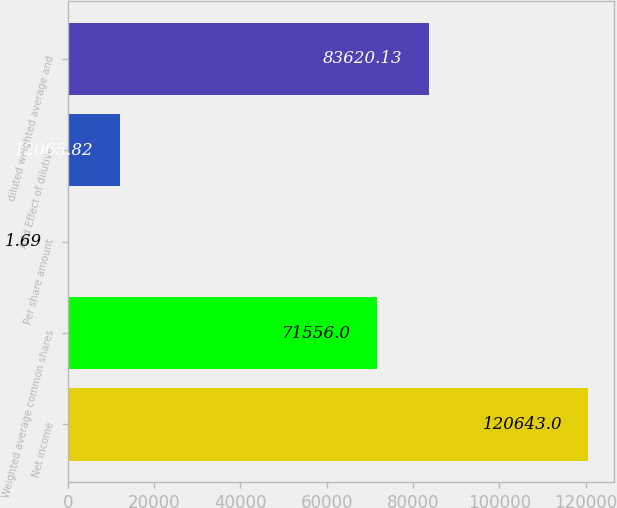<chart> <loc_0><loc_0><loc_500><loc_500><bar_chart><fcel>Net income<fcel>Weighted average common shares<fcel>Per share amount<fcel>Add Effect of dilutive<fcel>diluted weighted average and<nl><fcel>120643<fcel>71556<fcel>1.69<fcel>12065.8<fcel>83620.1<nl></chart> 